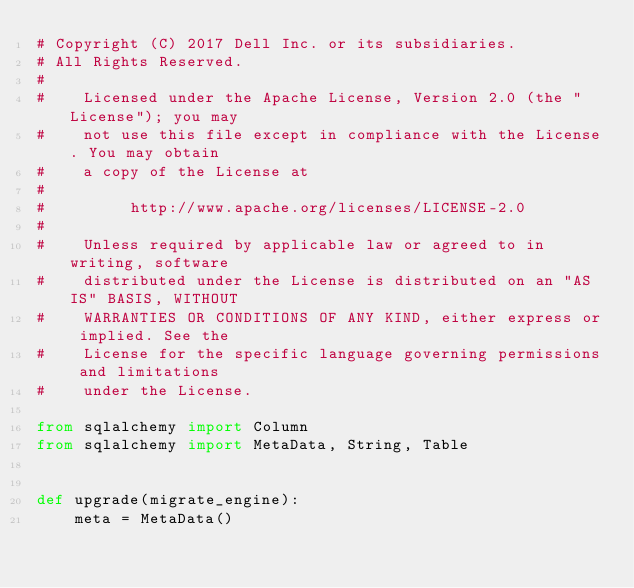<code> <loc_0><loc_0><loc_500><loc_500><_Python_># Copyright (C) 2017 Dell Inc. or its subsidiaries.
# All Rights Reserved.
#
#    Licensed under the Apache License, Version 2.0 (the "License"); you may
#    not use this file except in compliance with the License. You may obtain
#    a copy of the License at
#
#         http://www.apache.org/licenses/LICENSE-2.0
#
#    Unless required by applicable law or agreed to in writing, software
#    distributed under the License is distributed on an "AS IS" BASIS, WITHOUT
#    WARRANTIES OR CONDITIONS OF ANY KIND, either express or implied. See the
#    License for the specific language governing permissions and limitations
#    under the License.

from sqlalchemy import Column
from sqlalchemy import MetaData, String, Table


def upgrade(migrate_engine):
    meta = MetaData()</code> 